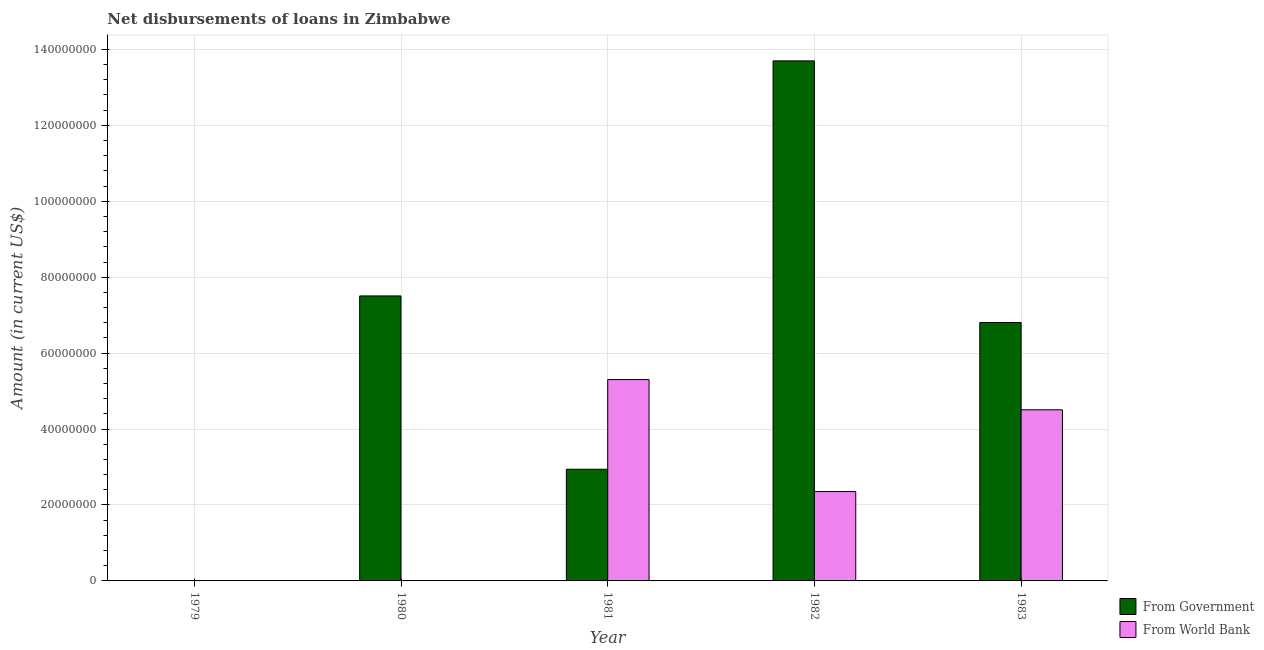How many bars are there on the 4th tick from the left?
Make the answer very short. 2. What is the label of the 5th group of bars from the left?
Give a very brief answer. 1983. In how many cases, is the number of bars for a given year not equal to the number of legend labels?
Your response must be concise. 2. What is the net disbursements of loan from world bank in 1983?
Give a very brief answer. 4.51e+07. Across all years, what is the maximum net disbursements of loan from world bank?
Your answer should be compact. 5.30e+07. Across all years, what is the minimum net disbursements of loan from government?
Ensure brevity in your answer.  0. In which year was the net disbursements of loan from government maximum?
Offer a terse response. 1982. What is the total net disbursements of loan from government in the graph?
Offer a very short reply. 3.10e+08. What is the difference between the net disbursements of loan from government in 1980 and that in 1983?
Keep it short and to the point. 7.00e+06. What is the difference between the net disbursements of loan from world bank in 1980 and the net disbursements of loan from government in 1982?
Offer a very short reply. -2.35e+07. What is the average net disbursements of loan from government per year?
Provide a short and direct response. 6.19e+07. In the year 1982, what is the difference between the net disbursements of loan from government and net disbursements of loan from world bank?
Give a very brief answer. 0. In how many years, is the net disbursements of loan from world bank greater than 72000000 US$?
Offer a very short reply. 0. What is the ratio of the net disbursements of loan from government in 1981 to that in 1983?
Ensure brevity in your answer.  0.43. Is the difference between the net disbursements of loan from government in 1980 and 1983 greater than the difference between the net disbursements of loan from world bank in 1980 and 1983?
Provide a short and direct response. No. What is the difference between the highest and the second highest net disbursements of loan from world bank?
Your answer should be very brief. 7.96e+06. What is the difference between the highest and the lowest net disbursements of loan from government?
Make the answer very short. 1.37e+08. How many bars are there?
Give a very brief answer. 7. Are all the bars in the graph horizontal?
Your response must be concise. No. What is the difference between two consecutive major ticks on the Y-axis?
Keep it short and to the point. 2.00e+07. Does the graph contain any zero values?
Your answer should be very brief. Yes. Does the graph contain grids?
Offer a very short reply. Yes. What is the title of the graph?
Keep it short and to the point. Net disbursements of loans in Zimbabwe. Does "Urban" appear as one of the legend labels in the graph?
Keep it short and to the point. No. What is the label or title of the Y-axis?
Your answer should be very brief. Amount (in current US$). What is the Amount (in current US$) of From World Bank in 1979?
Keep it short and to the point. 0. What is the Amount (in current US$) in From Government in 1980?
Ensure brevity in your answer.  7.51e+07. What is the Amount (in current US$) of From World Bank in 1980?
Make the answer very short. 0. What is the Amount (in current US$) of From Government in 1981?
Provide a short and direct response. 2.94e+07. What is the Amount (in current US$) of From World Bank in 1981?
Your answer should be compact. 5.30e+07. What is the Amount (in current US$) in From Government in 1982?
Ensure brevity in your answer.  1.37e+08. What is the Amount (in current US$) of From World Bank in 1982?
Offer a terse response. 2.35e+07. What is the Amount (in current US$) of From Government in 1983?
Make the answer very short. 6.81e+07. What is the Amount (in current US$) in From World Bank in 1983?
Your response must be concise. 4.51e+07. Across all years, what is the maximum Amount (in current US$) in From Government?
Ensure brevity in your answer.  1.37e+08. Across all years, what is the maximum Amount (in current US$) in From World Bank?
Make the answer very short. 5.30e+07. Across all years, what is the minimum Amount (in current US$) of From Government?
Ensure brevity in your answer.  0. Across all years, what is the minimum Amount (in current US$) of From World Bank?
Ensure brevity in your answer.  0. What is the total Amount (in current US$) of From Government in the graph?
Provide a succinct answer. 3.10e+08. What is the total Amount (in current US$) in From World Bank in the graph?
Offer a very short reply. 1.22e+08. What is the difference between the Amount (in current US$) of From Government in 1980 and that in 1981?
Your response must be concise. 4.57e+07. What is the difference between the Amount (in current US$) of From Government in 1980 and that in 1982?
Give a very brief answer. -6.19e+07. What is the difference between the Amount (in current US$) of From Government in 1980 and that in 1983?
Your answer should be very brief. 7.00e+06. What is the difference between the Amount (in current US$) in From Government in 1981 and that in 1982?
Ensure brevity in your answer.  -1.08e+08. What is the difference between the Amount (in current US$) in From World Bank in 1981 and that in 1982?
Give a very brief answer. 2.95e+07. What is the difference between the Amount (in current US$) of From Government in 1981 and that in 1983?
Your response must be concise. -3.87e+07. What is the difference between the Amount (in current US$) of From World Bank in 1981 and that in 1983?
Ensure brevity in your answer.  7.96e+06. What is the difference between the Amount (in current US$) in From Government in 1982 and that in 1983?
Your answer should be compact. 6.89e+07. What is the difference between the Amount (in current US$) of From World Bank in 1982 and that in 1983?
Your response must be concise. -2.15e+07. What is the difference between the Amount (in current US$) of From Government in 1980 and the Amount (in current US$) of From World Bank in 1981?
Ensure brevity in your answer.  2.20e+07. What is the difference between the Amount (in current US$) of From Government in 1980 and the Amount (in current US$) of From World Bank in 1982?
Keep it short and to the point. 5.15e+07. What is the difference between the Amount (in current US$) in From Government in 1980 and the Amount (in current US$) in From World Bank in 1983?
Offer a terse response. 3.00e+07. What is the difference between the Amount (in current US$) in From Government in 1981 and the Amount (in current US$) in From World Bank in 1982?
Give a very brief answer. 5.88e+06. What is the difference between the Amount (in current US$) in From Government in 1981 and the Amount (in current US$) in From World Bank in 1983?
Offer a terse response. -1.57e+07. What is the difference between the Amount (in current US$) of From Government in 1982 and the Amount (in current US$) of From World Bank in 1983?
Your response must be concise. 9.19e+07. What is the average Amount (in current US$) of From Government per year?
Offer a terse response. 6.19e+07. What is the average Amount (in current US$) in From World Bank per year?
Your response must be concise. 2.43e+07. In the year 1981, what is the difference between the Amount (in current US$) of From Government and Amount (in current US$) of From World Bank?
Your answer should be compact. -2.36e+07. In the year 1982, what is the difference between the Amount (in current US$) in From Government and Amount (in current US$) in From World Bank?
Keep it short and to the point. 1.13e+08. In the year 1983, what is the difference between the Amount (in current US$) of From Government and Amount (in current US$) of From World Bank?
Your answer should be compact. 2.30e+07. What is the ratio of the Amount (in current US$) of From Government in 1980 to that in 1981?
Your answer should be very brief. 2.55. What is the ratio of the Amount (in current US$) of From Government in 1980 to that in 1982?
Ensure brevity in your answer.  0.55. What is the ratio of the Amount (in current US$) in From Government in 1980 to that in 1983?
Offer a very short reply. 1.1. What is the ratio of the Amount (in current US$) in From Government in 1981 to that in 1982?
Make the answer very short. 0.21. What is the ratio of the Amount (in current US$) in From World Bank in 1981 to that in 1982?
Provide a short and direct response. 2.25. What is the ratio of the Amount (in current US$) in From Government in 1981 to that in 1983?
Offer a very short reply. 0.43. What is the ratio of the Amount (in current US$) of From World Bank in 1981 to that in 1983?
Provide a succinct answer. 1.18. What is the ratio of the Amount (in current US$) in From Government in 1982 to that in 1983?
Give a very brief answer. 2.01. What is the ratio of the Amount (in current US$) in From World Bank in 1982 to that in 1983?
Your answer should be compact. 0.52. What is the difference between the highest and the second highest Amount (in current US$) of From Government?
Keep it short and to the point. 6.19e+07. What is the difference between the highest and the second highest Amount (in current US$) in From World Bank?
Offer a terse response. 7.96e+06. What is the difference between the highest and the lowest Amount (in current US$) of From Government?
Keep it short and to the point. 1.37e+08. What is the difference between the highest and the lowest Amount (in current US$) in From World Bank?
Give a very brief answer. 5.30e+07. 